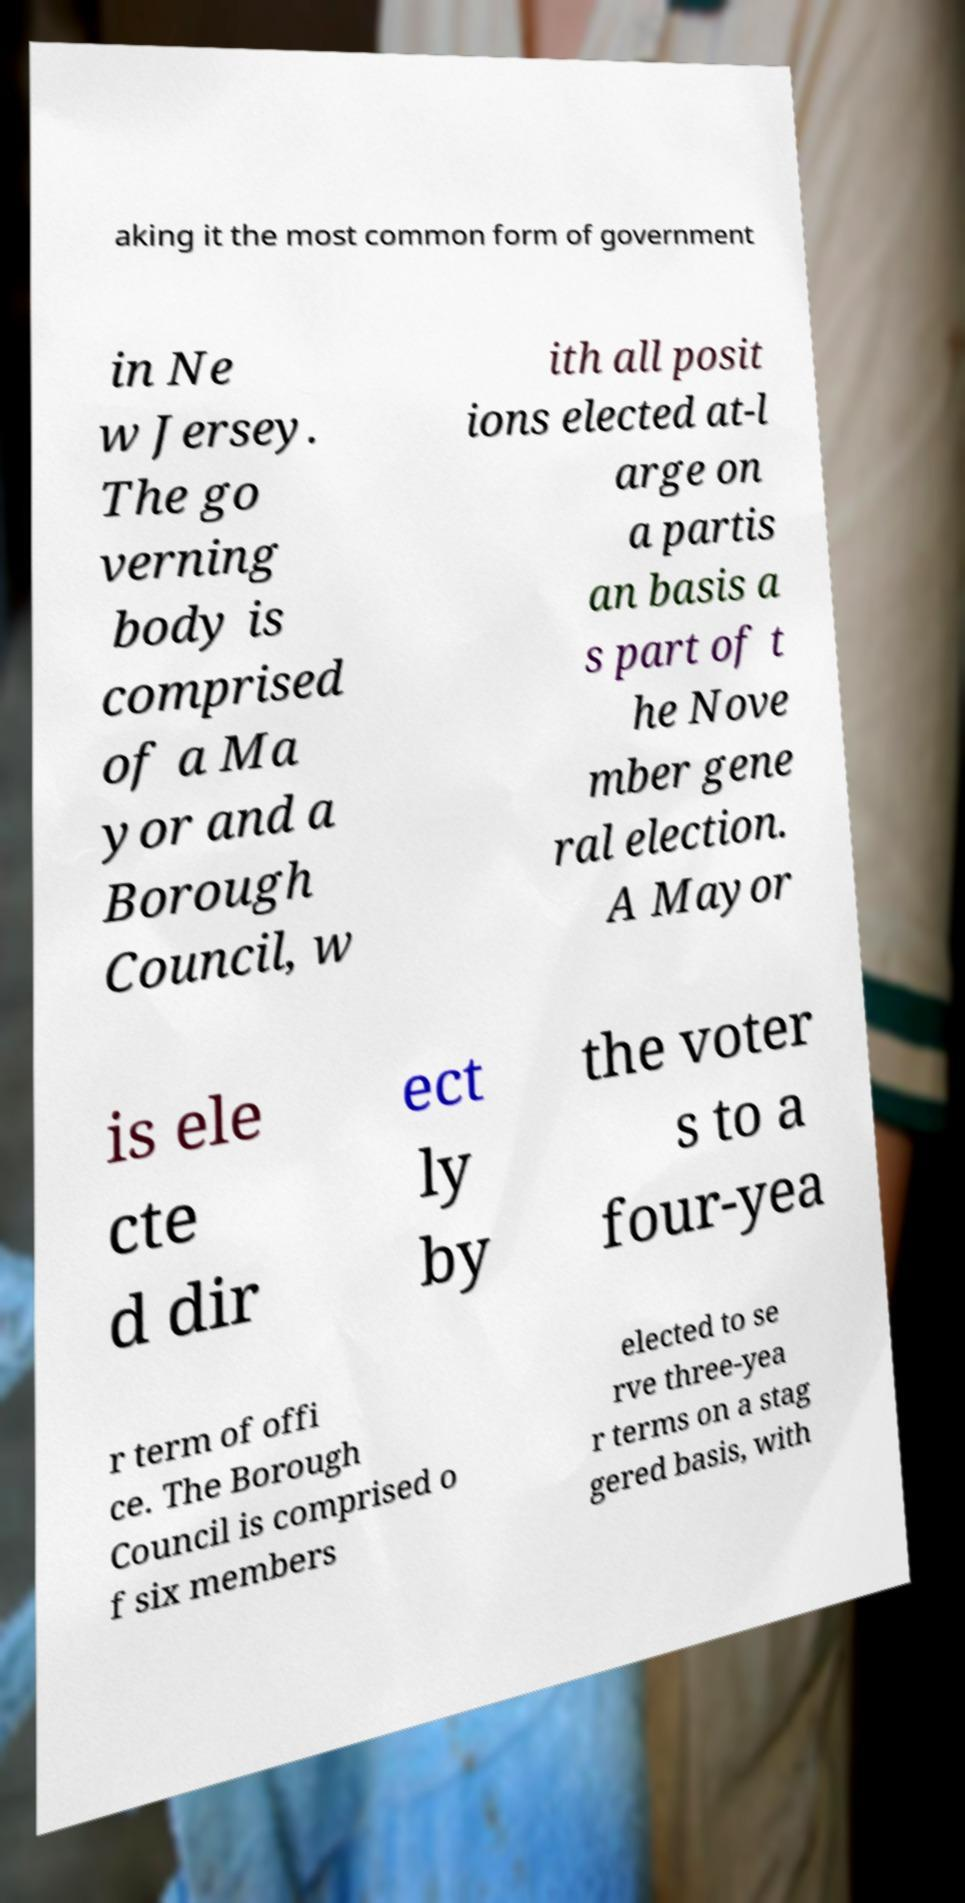I need the written content from this picture converted into text. Can you do that? aking it the most common form of government in Ne w Jersey. The go verning body is comprised of a Ma yor and a Borough Council, w ith all posit ions elected at-l arge on a partis an basis a s part of t he Nove mber gene ral election. A Mayor is ele cte d dir ect ly by the voter s to a four-yea r term of offi ce. The Borough Council is comprised o f six members elected to se rve three-yea r terms on a stag gered basis, with 